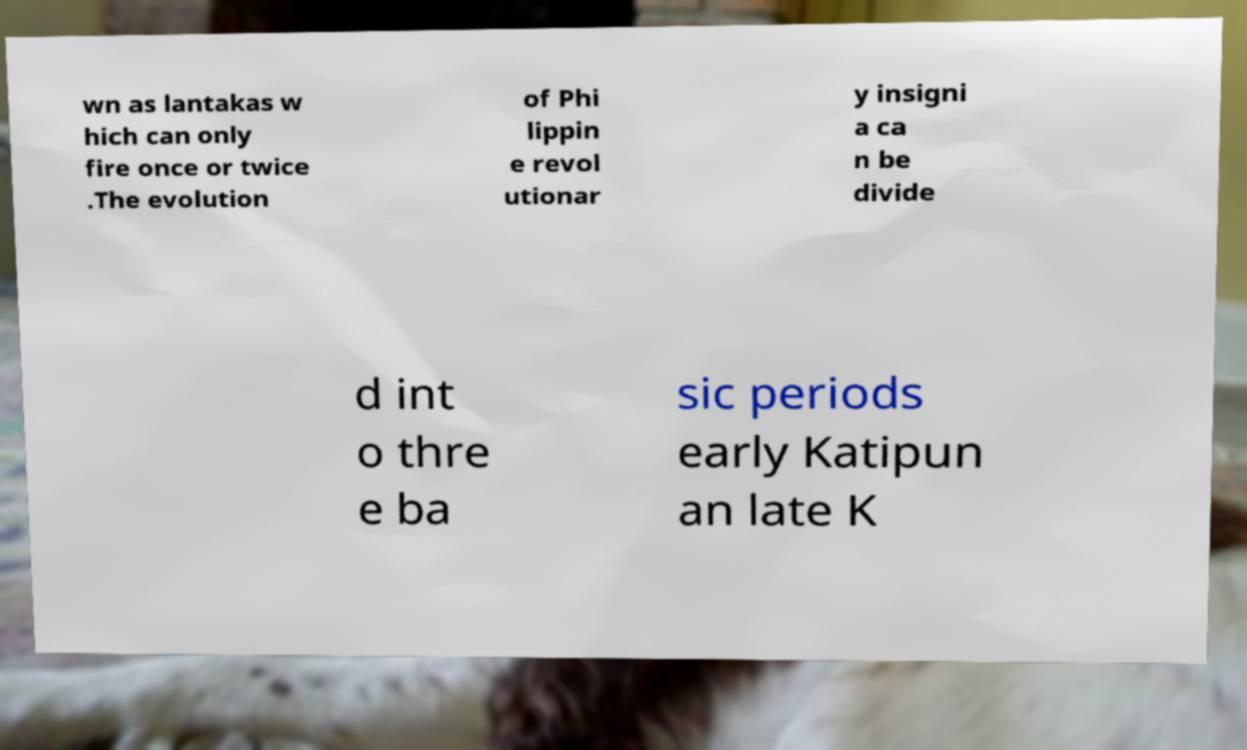Could you extract and type out the text from this image? wn as lantakas w hich can only fire once or twice .The evolution of Phi lippin e revol utionar y insigni a ca n be divide d int o thre e ba sic periods early Katipun an late K 